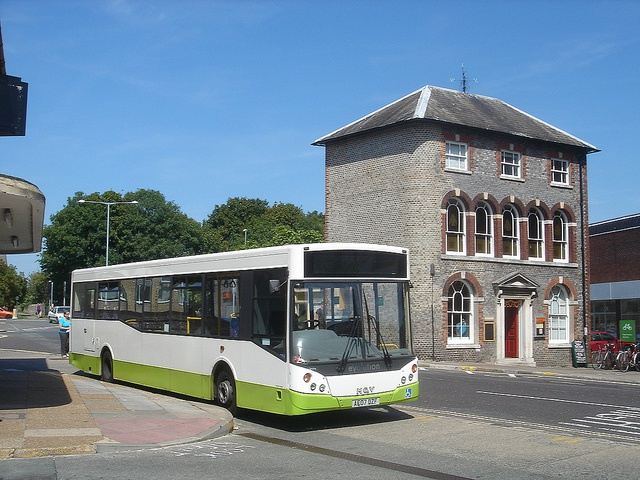Describe the objects in this image and their specific colors. I can see bus in gray, black, lightgray, and darkgray tones, car in gray, black, maroon, and brown tones, people in gray, black, and cyan tones, bicycle in gray, black, darkgray, and maroon tones, and bicycle in gray, black, and maroon tones in this image. 